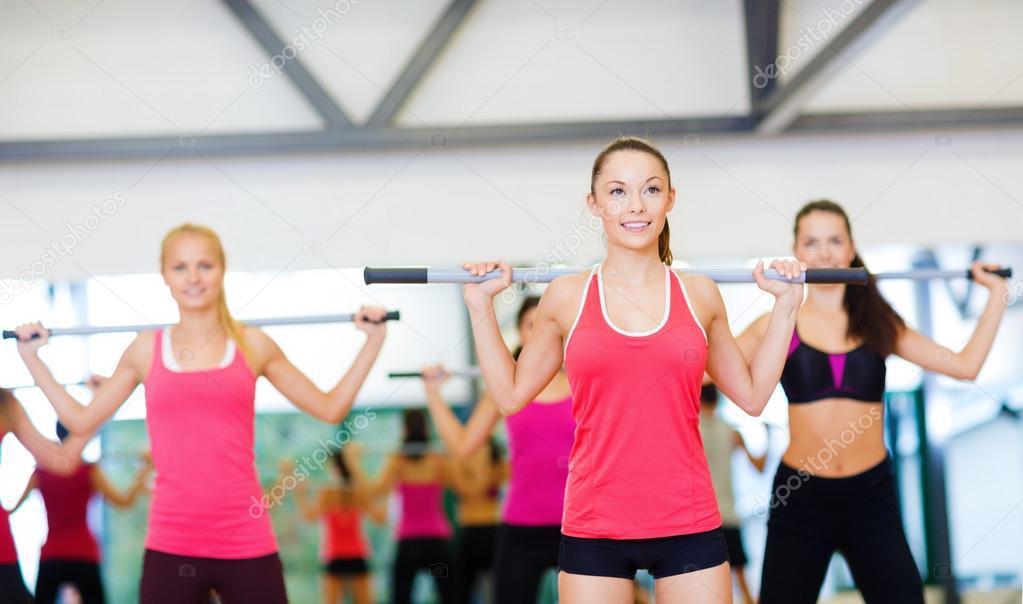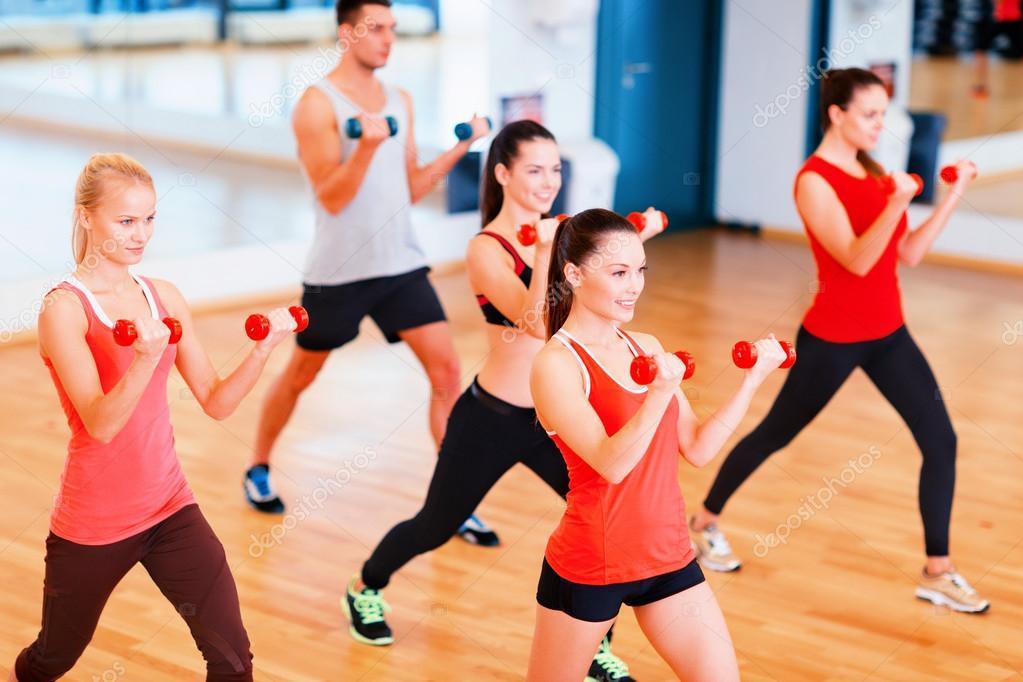The first image is the image on the left, the second image is the image on the right. Considering the images on both sides, is "One image shows a man holding something weighted in each hand, standing in front of at least four women doing the same workout." valid? Answer yes or no. No. The first image is the image on the left, the second image is the image on the right. Considering the images on both sides, is "In at least one image there are three people lifting weights." valid? Answer yes or no. No. 